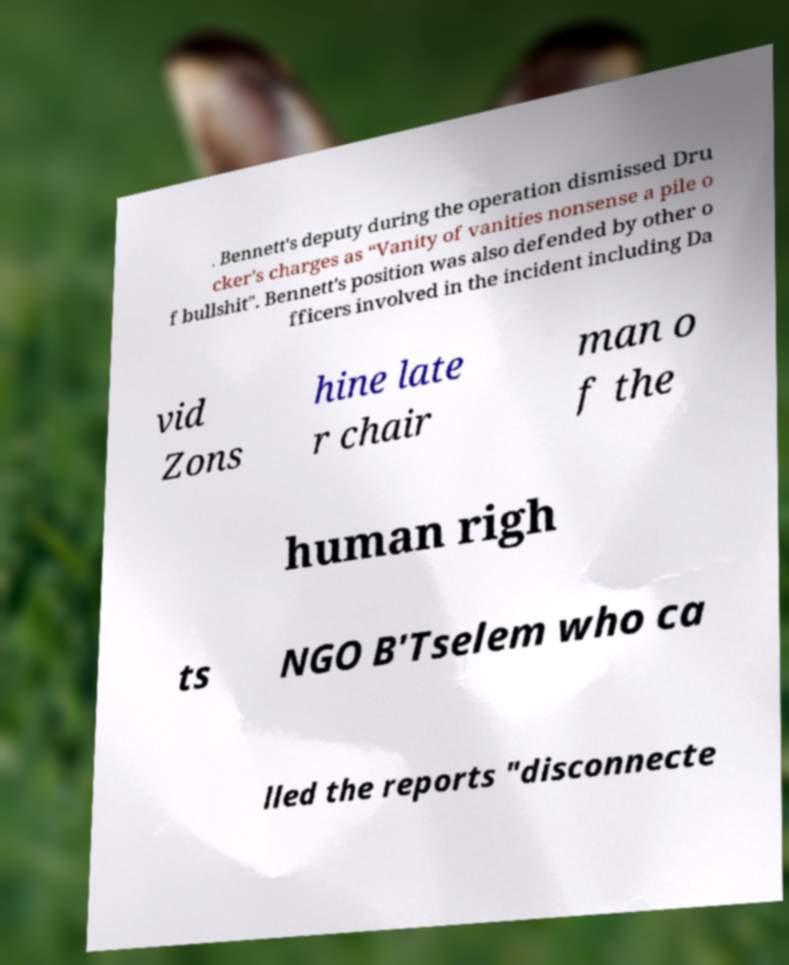Could you assist in decoding the text presented in this image and type it out clearly? . Bennett's deputy during the operation dismissed Dru cker's charges as “Vanity of vanities nonsense a pile o f bullshit". Bennett's position was also defended by other o fficers involved in the incident including Da vid Zons hine late r chair man o f the human righ ts NGO B'Tselem who ca lled the reports "disconnecte 